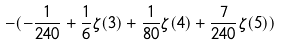<formula> <loc_0><loc_0><loc_500><loc_500>- ( - \frac { 1 } { 2 4 0 } + \frac { 1 } { 6 } \zeta ( 3 ) + \frac { 1 } { 8 0 } \zeta ( 4 ) + \frac { 7 } { 2 4 0 } \zeta ( 5 ) )</formula> 